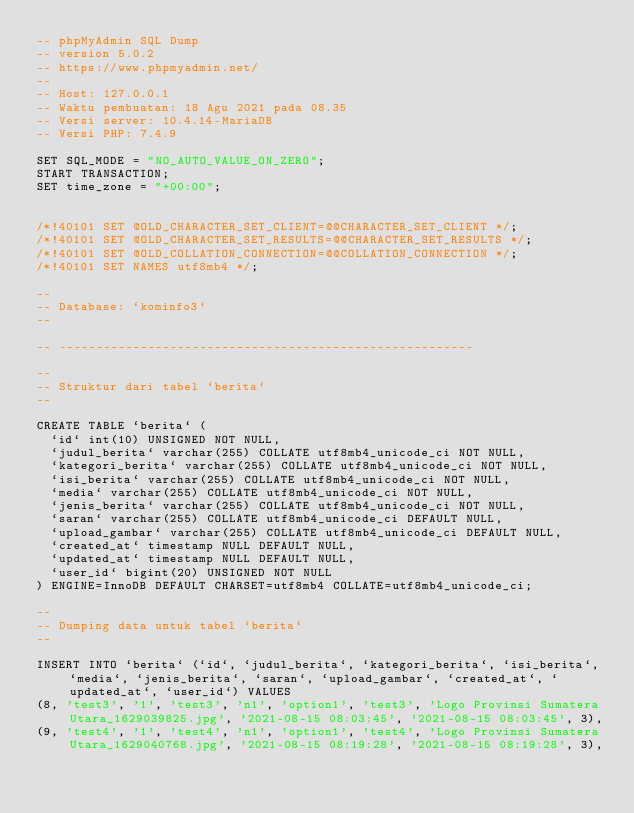<code> <loc_0><loc_0><loc_500><loc_500><_SQL_>-- phpMyAdmin SQL Dump
-- version 5.0.2
-- https://www.phpmyadmin.net/
--
-- Host: 127.0.0.1
-- Waktu pembuatan: 18 Agu 2021 pada 08.35
-- Versi server: 10.4.14-MariaDB
-- Versi PHP: 7.4.9

SET SQL_MODE = "NO_AUTO_VALUE_ON_ZERO";
START TRANSACTION;
SET time_zone = "+00:00";


/*!40101 SET @OLD_CHARACTER_SET_CLIENT=@@CHARACTER_SET_CLIENT */;
/*!40101 SET @OLD_CHARACTER_SET_RESULTS=@@CHARACTER_SET_RESULTS */;
/*!40101 SET @OLD_COLLATION_CONNECTION=@@COLLATION_CONNECTION */;
/*!40101 SET NAMES utf8mb4 */;

--
-- Database: `kominfo3`
--

-- --------------------------------------------------------

--
-- Struktur dari tabel `berita`
--

CREATE TABLE `berita` (
  `id` int(10) UNSIGNED NOT NULL,
  `judul_berita` varchar(255) COLLATE utf8mb4_unicode_ci NOT NULL,
  `kategori_berita` varchar(255) COLLATE utf8mb4_unicode_ci NOT NULL,
  `isi_berita` varchar(255) COLLATE utf8mb4_unicode_ci NOT NULL,
  `media` varchar(255) COLLATE utf8mb4_unicode_ci NOT NULL,
  `jenis_berita` varchar(255) COLLATE utf8mb4_unicode_ci NOT NULL,
  `saran` varchar(255) COLLATE utf8mb4_unicode_ci DEFAULT NULL,
  `upload_gambar` varchar(255) COLLATE utf8mb4_unicode_ci DEFAULT NULL,
  `created_at` timestamp NULL DEFAULT NULL,
  `updated_at` timestamp NULL DEFAULT NULL,
  `user_id` bigint(20) UNSIGNED NOT NULL
) ENGINE=InnoDB DEFAULT CHARSET=utf8mb4 COLLATE=utf8mb4_unicode_ci;

--
-- Dumping data untuk tabel `berita`
--

INSERT INTO `berita` (`id`, `judul_berita`, `kategori_berita`, `isi_berita`, `media`, `jenis_berita`, `saran`, `upload_gambar`, `created_at`, `updated_at`, `user_id`) VALUES
(8, 'test3', '1', 'test3', 'n1', 'option1', 'test3', 'Logo Provinsi Sumatera Utara_1629039825.jpg', '2021-08-15 08:03:45', '2021-08-15 08:03:45', 3),
(9, 'test4', '1', 'test4', 'n1', 'option1', 'test4', 'Logo Provinsi Sumatera Utara_1629040768.jpg', '2021-08-15 08:19:28', '2021-08-15 08:19:28', 3),</code> 